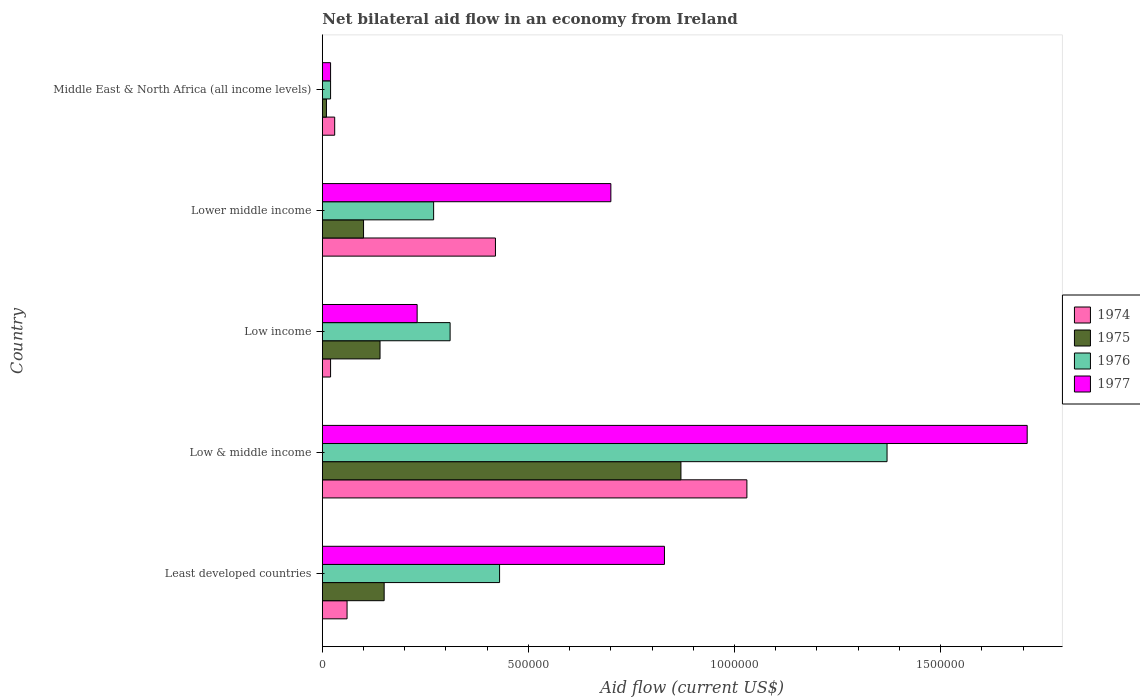How many different coloured bars are there?
Your answer should be compact. 4. How many groups of bars are there?
Provide a succinct answer. 5. Are the number of bars on each tick of the Y-axis equal?
Offer a very short reply. Yes. How many bars are there on the 3rd tick from the top?
Your response must be concise. 4. What is the label of the 4th group of bars from the top?
Make the answer very short. Low & middle income. In how many cases, is the number of bars for a given country not equal to the number of legend labels?
Your response must be concise. 0. What is the net bilateral aid flow in 1975 in Low & middle income?
Keep it short and to the point. 8.70e+05. Across all countries, what is the maximum net bilateral aid flow in 1976?
Keep it short and to the point. 1.37e+06. Across all countries, what is the minimum net bilateral aid flow in 1977?
Make the answer very short. 2.00e+04. In which country was the net bilateral aid flow in 1975 minimum?
Ensure brevity in your answer.  Middle East & North Africa (all income levels). What is the total net bilateral aid flow in 1976 in the graph?
Give a very brief answer. 2.40e+06. What is the difference between the net bilateral aid flow in 1974 in Least developed countries and that in Lower middle income?
Give a very brief answer. -3.60e+05. What is the difference between the net bilateral aid flow in 1975 in Lower middle income and the net bilateral aid flow in 1977 in Low & middle income?
Your answer should be very brief. -1.61e+06. What is the average net bilateral aid flow in 1975 per country?
Offer a very short reply. 2.54e+05. What is the difference between the net bilateral aid flow in 1975 and net bilateral aid flow in 1977 in Lower middle income?
Keep it short and to the point. -6.00e+05. In how many countries, is the net bilateral aid flow in 1975 greater than 400000 US$?
Make the answer very short. 1. Is the net bilateral aid flow in 1974 in Low income less than that in Lower middle income?
Give a very brief answer. Yes. What is the difference between the highest and the second highest net bilateral aid flow in 1977?
Offer a terse response. 8.80e+05. What is the difference between the highest and the lowest net bilateral aid flow in 1976?
Make the answer very short. 1.35e+06. Is it the case that in every country, the sum of the net bilateral aid flow in 1976 and net bilateral aid flow in 1974 is greater than the sum of net bilateral aid flow in 1977 and net bilateral aid flow in 1975?
Provide a short and direct response. No. What does the 4th bar from the top in Lower middle income represents?
Offer a very short reply. 1974. What does the 2nd bar from the bottom in Lower middle income represents?
Your response must be concise. 1975. Is it the case that in every country, the sum of the net bilateral aid flow in 1975 and net bilateral aid flow in 1974 is greater than the net bilateral aid flow in 1977?
Give a very brief answer. No. How many bars are there?
Your answer should be very brief. 20. Are the values on the major ticks of X-axis written in scientific E-notation?
Provide a short and direct response. No. Where does the legend appear in the graph?
Provide a short and direct response. Center right. How are the legend labels stacked?
Offer a terse response. Vertical. What is the title of the graph?
Your answer should be compact. Net bilateral aid flow in an economy from Ireland. Does "1976" appear as one of the legend labels in the graph?
Provide a succinct answer. Yes. What is the Aid flow (current US$) of 1974 in Least developed countries?
Ensure brevity in your answer.  6.00e+04. What is the Aid flow (current US$) in 1975 in Least developed countries?
Your answer should be compact. 1.50e+05. What is the Aid flow (current US$) in 1976 in Least developed countries?
Give a very brief answer. 4.30e+05. What is the Aid flow (current US$) in 1977 in Least developed countries?
Provide a short and direct response. 8.30e+05. What is the Aid flow (current US$) in 1974 in Low & middle income?
Ensure brevity in your answer.  1.03e+06. What is the Aid flow (current US$) of 1975 in Low & middle income?
Your response must be concise. 8.70e+05. What is the Aid flow (current US$) in 1976 in Low & middle income?
Offer a terse response. 1.37e+06. What is the Aid flow (current US$) in 1977 in Low & middle income?
Make the answer very short. 1.71e+06. What is the Aid flow (current US$) in 1974 in Low income?
Your answer should be compact. 2.00e+04. What is the Aid flow (current US$) of 1977 in Low income?
Provide a short and direct response. 2.30e+05. What is the Aid flow (current US$) of 1976 in Lower middle income?
Offer a terse response. 2.70e+05. What is the Aid flow (current US$) in 1976 in Middle East & North Africa (all income levels)?
Make the answer very short. 2.00e+04. What is the Aid flow (current US$) in 1977 in Middle East & North Africa (all income levels)?
Make the answer very short. 2.00e+04. Across all countries, what is the maximum Aid flow (current US$) in 1974?
Make the answer very short. 1.03e+06. Across all countries, what is the maximum Aid flow (current US$) in 1975?
Ensure brevity in your answer.  8.70e+05. Across all countries, what is the maximum Aid flow (current US$) in 1976?
Offer a very short reply. 1.37e+06. Across all countries, what is the maximum Aid flow (current US$) of 1977?
Provide a short and direct response. 1.71e+06. Across all countries, what is the minimum Aid flow (current US$) of 1975?
Your answer should be compact. 10000. Across all countries, what is the minimum Aid flow (current US$) of 1976?
Offer a terse response. 2.00e+04. What is the total Aid flow (current US$) in 1974 in the graph?
Keep it short and to the point. 1.56e+06. What is the total Aid flow (current US$) in 1975 in the graph?
Keep it short and to the point. 1.27e+06. What is the total Aid flow (current US$) of 1976 in the graph?
Provide a short and direct response. 2.40e+06. What is the total Aid flow (current US$) in 1977 in the graph?
Keep it short and to the point. 3.49e+06. What is the difference between the Aid flow (current US$) of 1974 in Least developed countries and that in Low & middle income?
Offer a very short reply. -9.70e+05. What is the difference between the Aid flow (current US$) in 1975 in Least developed countries and that in Low & middle income?
Your answer should be very brief. -7.20e+05. What is the difference between the Aid flow (current US$) in 1976 in Least developed countries and that in Low & middle income?
Provide a succinct answer. -9.40e+05. What is the difference between the Aid flow (current US$) of 1977 in Least developed countries and that in Low & middle income?
Give a very brief answer. -8.80e+05. What is the difference between the Aid flow (current US$) of 1974 in Least developed countries and that in Low income?
Your answer should be compact. 4.00e+04. What is the difference between the Aid flow (current US$) in 1975 in Least developed countries and that in Low income?
Offer a very short reply. 10000. What is the difference between the Aid flow (current US$) in 1977 in Least developed countries and that in Low income?
Your response must be concise. 6.00e+05. What is the difference between the Aid flow (current US$) of 1974 in Least developed countries and that in Lower middle income?
Give a very brief answer. -3.60e+05. What is the difference between the Aid flow (current US$) in 1975 in Least developed countries and that in Lower middle income?
Ensure brevity in your answer.  5.00e+04. What is the difference between the Aid flow (current US$) of 1976 in Least developed countries and that in Middle East & North Africa (all income levels)?
Keep it short and to the point. 4.10e+05. What is the difference between the Aid flow (current US$) in 1977 in Least developed countries and that in Middle East & North Africa (all income levels)?
Offer a very short reply. 8.10e+05. What is the difference between the Aid flow (current US$) in 1974 in Low & middle income and that in Low income?
Make the answer very short. 1.01e+06. What is the difference between the Aid flow (current US$) of 1975 in Low & middle income and that in Low income?
Offer a terse response. 7.30e+05. What is the difference between the Aid flow (current US$) in 1976 in Low & middle income and that in Low income?
Offer a terse response. 1.06e+06. What is the difference between the Aid flow (current US$) in 1977 in Low & middle income and that in Low income?
Provide a short and direct response. 1.48e+06. What is the difference between the Aid flow (current US$) of 1974 in Low & middle income and that in Lower middle income?
Your answer should be very brief. 6.10e+05. What is the difference between the Aid flow (current US$) of 1975 in Low & middle income and that in Lower middle income?
Offer a terse response. 7.70e+05. What is the difference between the Aid flow (current US$) of 1976 in Low & middle income and that in Lower middle income?
Provide a short and direct response. 1.10e+06. What is the difference between the Aid flow (current US$) of 1977 in Low & middle income and that in Lower middle income?
Offer a terse response. 1.01e+06. What is the difference between the Aid flow (current US$) of 1975 in Low & middle income and that in Middle East & North Africa (all income levels)?
Make the answer very short. 8.60e+05. What is the difference between the Aid flow (current US$) in 1976 in Low & middle income and that in Middle East & North Africa (all income levels)?
Your answer should be very brief. 1.35e+06. What is the difference between the Aid flow (current US$) in 1977 in Low & middle income and that in Middle East & North Africa (all income levels)?
Make the answer very short. 1.69e+06. What is the difference between the Aid flow (current US$) in 1974 in Low income and that in Lower middle income?
Keep it short and to the point. -4.00e+05. What is the difference between the Aid flow (current US$) of 1976 in Low income and that in Lower middle income?
Your response must be concise. 4.00e+04. What is the difference between the Aid flow (current US$) of 1977 in Low income and that in Lower middle income?
Your answer should be compact. -4.70e+05. What is the difference between the Aid flow (current US$) in 1974 in Low income and that in Middle East & North Africa (all income levels)?
Ensure brevity in your answer.  -10000. What is the difference between the Aid flow (current US$) of 1974 in Lower middle income and that in Middle East & North Africa (all income levels)?
Make the answer very short. 3.90e+05. What is the difference between the Aid flow (current US$) in 1977 in Lower middle income and that in Middle East & North Africa (all income levels)?
Your answer should be compact. 6.80e+05. What is the difference between the Aid flow (current US$) in 1974 in Least developed countries and the Aid flow (current US$) in 1975 in Low & middle income?
Give a very brief answer. -8.10e+05. What is the difference between the Aid flow (current US$) of 1974 in Least developed countries and the Aid flow (current US$) of 1976 in Low & middle income?
Give a very brief answer. -1.31e+06. What is the difference between the Aid flow (current US$) in 1974 in Least developed countries and the Aid flow (current US$) in 1977 in Low & middle income?
Provide a short and direct response. -1.65e+06. What is the difference between the Aid flow (current US$) in 1975 in Least developed countries and the Aid flow (current US$) in 1976 in Low & middle income?
Your answer should be compact. -1.22e+06. What is the difference between the Aid flow (current US$) of 1975 in Least developed countries and the Aid flow (current US$) of 1977 in Low & middle income?
Provide a short and direct response. -1.56e+06. What is the difference between the Aid flow (current US$) of 1976 in Least developed countries and the Aid flow (current US$) of 1977 in Low & middle income?
Provide a short and direct response. -1.28e+06. What is the difference between the Aid flow (current US$) of 1974 in Least developed countries and the Aid flow (current US$) of 1977 in Low income?
Make the answer very short. -1.70e+05. What is the difference between the Aid flow (current US$) in 1975 in Least developed countries and the Aid flow (current US$) in 1976 in Low income?
Make the answer very short. -1.60e+05. What is the difference between the Aid flow (current US$) in 1975 in Least developed countries and the Aid flow (current US$) in 1977 in Low income?
Provide a short and direct response. -8.00e+04. What is the difference between the Aid flow (current US$) of 1976 in Least developed countries and the Aid flow (current US$) of 1977 in Low income?
Your answer should be compact. 2.00e+05. What is the difference between the Aid flow (current US$) in 1974 in Least developed countries and the Aid flow (current US$) in 1975 in Lower middle income?
Your answer should be compact. -4.00e+04. What is the difference between the Aid flow (current US$) in 1974 in Least developed countries and the Aid flow (current US$) in 1977 in Lower middle income?
Give a very brief answer. -6.40e+05. What is the difference between the Aid flow (current US$) of 1975 in Least developed countries and the Aid flow (current US$) of 1976 in Lower middle income?
Give a very brief answer. -1.20e+05. What is the difference between the Aid flow (current US$) of 1975 in Least developed countries and the Aid flow (current US$) of 1977 in Lower middle income?
Provide a short and direct response. -5.50e+05. What is the difference between the Aid flow (current US$) in 1976 in Least developed countries and the Aid flow (current US$) in 1977 in Lower middle income?
Give a very brief answer. -2.70e+05. What is the difference between the Aid flow (current US$) of 1974 in Least developed countries and the Aid flow (current US$) of 1977 in Middle East & North Africa (all income levels)?
Your response must be concise. 4.00e+04. What is the difference between the Aid flow (current US$) in 1975 in Least developed countries and the Aid flow (current US$) in 1976 in Middle East & North Africa (all income levels)?
Your answer should be compact. 1.30e+05. What is the difference between the Aid flow (current US$) of 1976 in Least developed countries and the Aid flow (current US$) of 1977 in Middle East & North Africa (all income levels)?
Your response must be concise. 4.10e+05. What is the difference between the Aid flow (current US$) in 1974 in Low & middle income and the Aid flow (current US$) in 1975 in Low income?
Offer a terse response. 8.90e+05. What is the difference between the Aid flow (current US$) of 1974 in Low & middle income and the Aid flow (current US$) of 1976 in Low income?
Your answer should be very brief. 7.20e+05. What is the difference between the Aid flow (current US$) in 1974 in Low & middle income and the Aid flow (current US$) in 1977 in Low income?
Give a very brief answer. 8.00e+05. What is the difference between the Aid flow (current US$) in 1975 in Low & middle income and the Aid flow (current US$) in 1976 in Low income?
Your answer should be very brief. 5.60e+05. What is the difference between the Aid flow (current US$) in 1975 in Low & middle income and the Aid flow (current US$) in 1977 in Low income?
Offer a terse response. 6.40e+05. What is the difference between the Aid flow (current US$) in 1976 in Low & middle income and the Aid flow (current US$) in 1977 in Low income?
Your response must be concise. 1.14e+06. What is the difference between the Aid flow (current US$) in 1974 in Low & middle income and the Aid flow (current US$) in 1975 in Lower middle income?
Provide a succinct answer. 9.30e+05. What is the difference between the Aid flow (current US$) of 1974 in Low & middle income and the Aid flow (current US$) of 1976 in Lower middle income?
Keep it short and to the point. 7.60e+05. What is the difference between the Aid flow (current US$) in 1974 in Low & middle income and the Aid flow (current US$) in 1977 in Lower middle income?
Give a very brief answer. 3.30e+05. What is the difference between the Aid flow (current US$) of 1975 in Low & middle income and the Aid flow (current US$) of 1976 in Lower middle income?
Make the answer very short. 6.00e+05. What is the difference between the Aid flow (current US$) in 1976 in Low & middle income and the Aid flow (current US$) in 1977 in Lower middle income?
Provide a succinct answer. 6.70e+05. What is the difference between the Aid flow (current US$) in 1974 in Low & middle income and the Aid flow (current US$) in 1975 in Middle East & North Africa (all income levels)?
Offer a very short reply. 1.02e+06. What is the difference between the Aid flow (current US$) in 1974 in Low & middle income and the Aid flow (current US$) in 1976 in Middle East & North Africa (all income levels)?
Offer a very short reply. 1.01e+06. What is the difference between the Aid flow (current US$) in 1974 in Low & middle income and the Aid flow (current US$) in 1977 in Middle East & North Africa (all income levels)?
Your response must be concise. 1.01e+06. What is the difference between the Aid flow (current US$) of 1975 in Low & middle income and the Aid flow (current US$) of 1976 in Middle East & North Africa (all income levels)?
Provide a short and direct response. 8.50e+05. What is the difference between the Aid flow (current US$) in 1975 in Low & middle income and the Aid flow (current US$) in 1977 in Middle East & North Africa (all income levels)?
Offer a very short reply. 8.50e+05. What is the difference between the Aid flow (current US$) of 1976 in Low & middle income and the Aid flow (current US$) of 1977 in Middle East & North Africa (all income levels)?
Your answer should be compact. 1.35e+06. What is the difference between the Aid flow (current US$) of 1974 in Low income and the Aid flow (current US$) of 1975 in Lower middle income?
Offer a very short reply. -8.00e+04. What is the difference between the Aid flow (current US$) in 1974 in Low income and the Aid flow (current US$) in 1976 in Lower middle income?
Ensure brevity in your answer.  -2.50e+05. What is the difference between the Aid flow (current US$) of 1974 in Low income and the Aid flow (current US$) of 1977 in Lower middle income?
Keep it short and to the point. -6.80e+05. What is the difference between the Aid flow (current US$) of 1975 in Low income and the Aid flow (current US$) of 1976 in Lower middle income?
Make the answer very short. -1.30e+05. What is the difference between the Aid flow (current US$) in 1975 in Low income and the Aid flow (current US$) in 1977 in Lower middle income?
Give a very brief answer. -5.60e+05. What is the difference between the Aid flow (current US$) in 1976 in Low income and the Aid flow (current US$) in 1977 in Lower middle income?
Offer a very short reply. -3.90e+05. What is the difference between the Aid flow (current US$) of 1974 in Low income and the Aid flow (current US$) of 1975 in Middle East & North Africa (all income levels)?
Your answer should be very brief. 10000. What is the difference between the Aid flow (current US$) in 1974 in Low income and the Aid flow (current US$) in 1976 in Middle East & North Africa (all income levels)?
Make the answer very short. 0. What is the difference between the Aid flow (current US$) in 1974 in Low income and the Aid flow (current US$) in 1977 in Middle East & North Africa (all income levels)?
Offer a terse response. 0. What is the difference between the Aid flow (current US$) of 1974 in Lower middle income and the Aid flow (current US$) of 1976 in Middle East & North Africa (all income levels)?
Offer a very short reply. 4.00e+05. What is the difference between the Aid flow (current US$) of 1975 in Lower middle income and the Aid flow (current US$) of 1977 in Middle East & North Africa (all income levels)?
Your answer should be very brief. 8.00e+04. What is the difference between the Aid flow (current US$) of 1976 in Lower middle income and the Aid flow (current US$) of 1977 in Middle East & North Africa (all income levels)?
Provide a short and direct response. 2.50e+05. What is the average Aid flow (current US$) of 1974 per country?
Your answer should be very brief. 3.12e+05. What is the average Aid flow (current US$) of 1975 per country?
Ensure brevity in your answer.  2.54e+05. What is the average Aid flow (current US$) in 1976 per country?
Provide a succinct answer. 4.80e+05. What is the average Aid flow (current US$) in 1977 per country?
Your response must be concise. 6.98e+05. What is the difference between the Aid flow (current US$) of 1974 and Aid flow (current US$) of 1975 in Least developed countries?
Your response must be concise. -9.00e+04. What is the difference between the Aid flow (current US$) of 1974 and Aid flow (current US$) of 1976 in Least developed countries?
Provide a short and direct response. -3.70e+05. What is the difference between the Aid flow (current US$) in 1974 and Aid flow (current US$) in 1977 in Least developed countries?
Make the answer very short. -7.70e+05. What is the difference between the Aid flow (current US$) of 1975 and Aid flow (current US$) of 1976 in Least developed countries?
Give a very brief answer. -2.80e+05. What is the difference between the Aid flow (current US$) in 1975 and Aid flow (current US$) in 1977 in Least developed countries?
Your response must be concise. -6.80e+05. What is the difference between the Aid flow (current US$) of 1976 and Aid flow (current US$) of 1977 in Least developed countries?
Ensure brevity in your answer.  -4.00e+05. What is the difference between the Aid flow (current US$) in 1974 and Aid flow (current US$) in 1976 in Low & middle income?
Provide a succinct answer. -3.40e+05. What is the difference between the Aid flow (current US$) of 1974 and Aid flow (current US$) of 1977 in Low & middle income?
Make the answer very short. -6.80e+05. What is the difference between the Aid flow (current US$) of 1975 and Aid flow (current US$) of 1976 in Low & middle income?
Ensure brevity in your answer.  -5.00e+05. What is the difference between the Aid flow (current US$) in 1975 and Aid flow (current US$) in 1977 in Low & middle income?
Your answer should be compact. -8.40e+05. What is the difference between the Aid flow (current US$) in 1976 and Aid flow (current US$) in 1977 in Low & middle income?
Provide a short and direct response. -3.40e+05. What is the difference between the Aid flow (current US$) of 1975 and Aid flow (current US$) of 1977 in Low income?
Your response must be concise. -9.00e+04. What is the difference between the Aid flow (current US$) of 1976 and Aid flow (current US$) of 1977 in Low income?
Give a very brief answer. 8.00e+04. What is the difference between the Aid flow (current US$) of 1974 and Aid flow (current US$) of 1977 in Lower middle income?
Your response must be concise. -2.80e+05. What is the difference between the Aid flow (current US$) in 1975 and Aid flow (current US$) in 1977 in Lower middle income?
Ensure brevity in your answer.  -6.00e+05. What is the difference between the Aid flow (current US$) in 1976 and Aid flow (current US$) in 1977 in Lower middle income?
Provide a succinct answer. -4.30e+05. What is the difference between the Aid flow (current US$) in 1974 and Aid flow (current US$) in 1976 in Middle East & North Africa (all income levels)?
Keep it short and to the point. 10000. What is the difference between the Aid flow (current US$) of 1974 and Aid flow (current US$) of 1977 in Middle East & North Africa (all income levels)?
Offer a terse response. 10000. What is the difference between the Aid flow (current US$) of 1976 and Aid flow (current US$) of 1977 in Middle East & North Africa (all income levels)?
Offer a very short reply. 0. What is the ratio of the Aid flow (current US$) in 1974 in Least developed countries to that in Low & middle income?
Give a very brief answer. 0.06. What is the ratio of the Aid flow (current US$) of 1975 in Least developed countries to that in Low & middle income?
Provide a succinct answer. 0.17. What is the ratio of the Aid flow (current US$) of 1976 in Least developed countries to that in Low & middle income?
Give a very brief answer. 0.31. What is the ratio of the Aid flow (current US$) in 1977 in Least developed countries to that in Low & middle income?
Keep it short and to the point. 0.49. What is the ratio of the Aid flow (current US$) of 1974 in Least developed countries to that in Low income?
Keep it short and to the point. 3. What is the ratio of the Aid flow (current US$) in 1975 in Least developed countries to that in Low income?
Provide a short and direct response. 1.07. What is the ratio of the Aid flow (current US$) in 1976 in Least developed countries to that in Low income?
Ensure brevity in your answer.  1.39. What is the ratio of the Aid flow (current US$) in 1977 in Least developed countries to that in Low income?
Offer a very short reply. 3.61. What is the ratio of the Aid flow (current US$) in 1974 in Least developed countries to that in Lower middle income?
Give a very brief answer. 0.14. What is the ratio of the Aid flow (current US$) of 1976 in Least developed countries to that in Lower middle income?
Your answer should be compact. 1.59. What is the ratio of the Aid flow (current US$) of 1977 in Least developed countries to that in Lower middle income?
Ensure brevity in your answer.  1.19. What is the ratio of the Aid flow (current US$) in 1974 in Least developed countries to that in Middle East & North Africa (all income levels)?
Ensure brevity in your answer.  2. What is the ratio of the Aid flow (current US$) in 1976 in Least developed countries to that in Middle East & North Africa (all income levels)?
Give a very brief answer. 21.5. What is the ratio of the Aid flow (current US$) in 1977 in Least developed countries to that in Middle East & North Africa (all income levels)?
Your response must be concise. 41.5. What is the ratio of the Aid flow (current US$) in 1974 in Low & middle income to that in Low income?
Make the answer very short. 51.5. What is the ratio of the Aid flow (current US$) in 1975 in Low & middle income to that in Low income?
Your answer should be very brief. 6.21. What is the ratio of the Aid flow (current US$) in 1976 in Low & middle income to that in Low income?
Offer a terse response. 4.42. What is the ratio of the Aid flow (current US$) of 1977 in Low & middle income to that in Low income?
Make the answer very short. 7.43. What is the ratio of the Aid flow (current US$) in 1974 in Low & middle income to that in Lower middle income?
Your answer should be compact. 2.45. What is the ratio of the Aid flow (current US$) of 1975 in Low & middle income to that in Lower middle income?
Your response must be concise. 8.7. What is the ratio of the Aid flow (current US$) in 1976 in Low & middle income to that in Lower middle income?
Give a very brief answer. 5.07. What is the ratio of the Aid flow (current US$) of 1977 in Low & middle income to that in Lower middle income?
Offer a very short reply. 2.44. What is the ratio of the Aid flow (current US$) of 1974 in Low & middle income to that in Middle East & North Africa (all income levels)?
Keep it short and to the point. 34.33. What is the ratio of the Aid flow (current US$) in 1976 in Low & middle income to that in Middle East & North Africa (all income levels)?
Make the answer very short. 68.5. What is the ratio of the Aid flow (current US$) in 1977 in Low & middle income to that in Middle East & North Africa (all income levels)?
Provide a short and direct response. 85.5. What is the ratio of the Aid flow (current US$) in 1974 in Low income to that in Lower middle income?
Keep it short and to the point. 0.05. What is the ratio of the Aid flow (current US$) of 1975 in Low income to that in Lower middle income?
Your answer should be very brief. 1.4. What is the ratio of the Aid flow (current US$) in 1976 in Low income to that in Lower middle income?
Make the answer very short. 1.15. What is the ratio of the Aid flow (current US$) of 1977 in Low income to that in Lower middle income?
Offer a terse response. 0.33. What is the ratio of the Aid flow (current US$) in 1974 in Low income to that in Middle East & North Africa (all income levels)?
Your answer should be compact. 0.67. What is the ratio of the Aid flow (current US$) of 1975 in Low income to that in Middle East & North Africa (all income levels)?
Offer a very short reply. 14. What is the ratio of the Aid flow (current US$) of 1976 in Low income to that in Middle East & North Africa (all income levels)?
Give a very brief answer. 15.5. What is the ratio of the Aid flow (current US$) of 1977 in Low income to that in Middle East & North Africa (all income levels)?
Give a very brief answer. 11.5. What is the ratio of the Aid flow (current US$) of 1974 in Lower middle income to that in Middle East & North Africa (all income levels)?
Provide a short and direct response. 14. What is the ratio of the Aid flow (current US$) of 1975 in Lower middle income to that in Middle East & North Africa (all income levels)?
Your answer should be compact. 10. What is the ratio of the Aid flow (current US$) of 1976 in Lower middle income to that in Middle East & North Africa (all income levels)?
Make the answer very short. 13.5. What is the ratio of the Aid flow (current US$) of 1977 in Lower middle income to that in Middle East & North Africa (all income levels)?
Your response must be concise. 35. What is the difference between the highest and the second highest Aid flow (current US$) in 1975?
Offer a very short reply. 7.20e+05. What is the difference between the highest and the second highest Aid flow (current US$) of 1976?
Your response must be concise. 9.40e+05. What is the difference between the highest and the second highest Aid flow (current US$) of 1977?
Provide a short and direct response. 8.80e+05. What is the difference between the highest and the lowest Aid flow (current US$) in 1974?
Make the answer very short. 1.01e+06. What is the difference between the highest and the lowest Aid flow (current US$) in 1975?
Provide a succinct answer. 8.60e+05. What is the difference between the highest and the lowest Aid flow (current US$) in 1976?
Provide a short and direct response. 1.35e+06. What is the difference between the highest and the lowest Aid flow (current US$) in 1977?
Make the answer very short. 1.69e+06. 